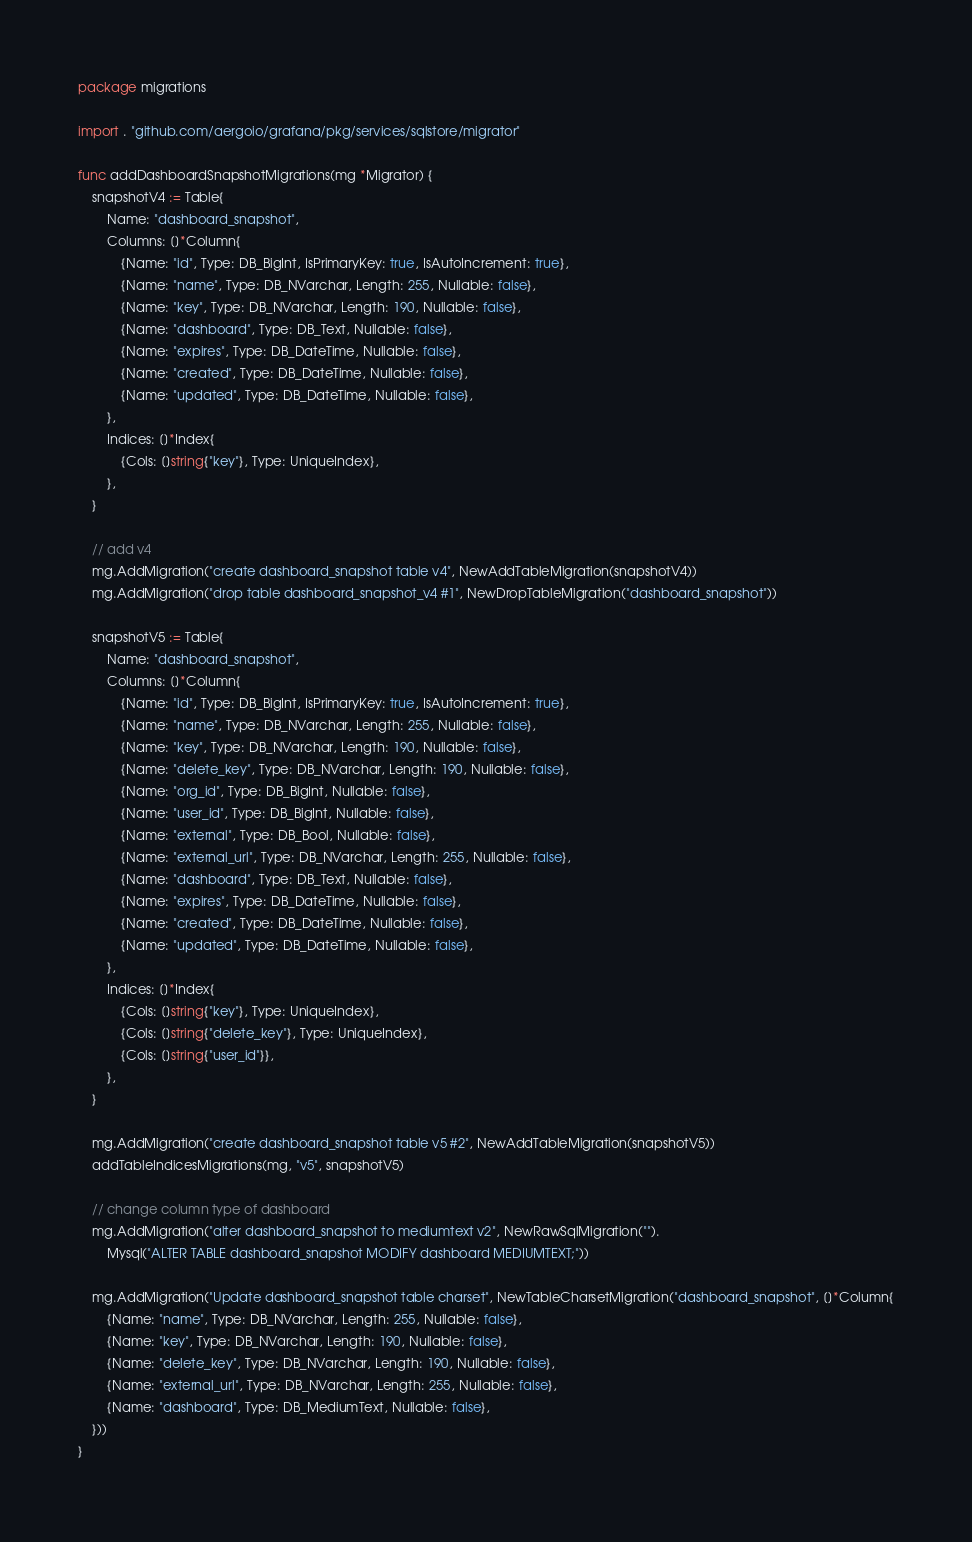<code> <loc_0><loc_0><loc_500><loc_500><_Go_>package migrations

import . "github.com/aergoio/grafana/pkg/services/sqlstore/migrator"

func addDashboardSnapshotMigrations(mg *Migrator) {
	snapshotV4 := Table{
		Name: "dashboard_snapshot",
		Columns: []*Column{
			{Name: "id", Type: DB_BigInt, IsPrimaryKey: true, IsAutoIncrement: true},
			{Name: "name", Type: DB_NVarchar, Length: 255, Nullable: false},
			{Name: "key", Type: DB_NVarchar, Length: 190, Nullable: false},
			{Name: "dashboard", Type: DB_Text, Nullable: false},
			{Name: "expires", Type: DB_DateTime, Nullable: false},
			{Name: "created", Type: DB_DateTime, Nullable: false},
			{Name: "updated", Type: DB_DateTime, Nullable: false},
		},
		Indices: []*Index{
			{Cols: []string{"key"}, Type: UniqueIndex},
		},
	}

	// add v4
	mg.AddMigration("create dashboard_snapshot table v4", NewAddTableMigration(snapshotV4))
	mg.AddMigration("drop table dashboard_snapshot_v4 #1", NewDropTableMigration("dashboard_snapshot"))

	snapshotV5 := Table{
		Name: "dashboard_snapshot",
		Columns: []*Column{
			{Name: "id", Type: DB_BigInt, IsPrimaryKey: true, IsAutoIncrement: true},
			{Name: "name", Type: DB_NVarchar, Length: 255, Nullable: false},
			{Name: "key", Type: DB_NVarchar, Length: 190, Nullable: false},
			{Name: "delete_key", Type: DB_NVarchar, Length: 190, Nullable: false},
			{Name: "org_id", Type: DB_BigInt, Nullable: false},
			{Name: "user_id", Type: DB_BigInt, Nullable: false},
			{Name: "external", Type: DB_Bool, Nullable: false},
			{Name: "external_url", Type: DB_NVarchar, Length: 255, Nullable: false},
			{Name: "dashboard", Type: DB_Text, Nullable: false},
			{Name: "expires", Type: DB_DateTime, Nullable: false},
			{Name: "created", Type: DB_DateTime, Nullable: false},
			{Name: "updated", Type: DB_DateTime, Nullable: false},
		},
		Indices: []*Index{
			{Cols: []string{"key"}, Type: UniqueIndex},
			{Cols: []string{"delete_key"}, Type: UniqueIndex},
			{Cols: []string{"user_id"}},
		},
	}

	mg.AddMigration("create dashboard_snapshot table v5 #2", NewAddTableMigration(snapshotV5))
	addTableIndicesMigrations(mg, "v5", snapshotV5)

	// change column type of dashboard
	mg.AddMigration("alter dashboard_snapshot to mediumtext v2", NewRawSqlMigration("").
		Mysql("ALTER TABLE dashboard_snapshot MODIFY dashboard MEDIUMTEXT;"))

	mg.AddMigration("Update dashboard_snapshot table charset", NewTableCharsetMigration("dashboard_snapshot", []*Column{
		{Name: "name", Type: DB_NVarchar, Length: 255, Nullable: false},
		{Name: "key", Type: DB_NVarchar, Length: 190, Nullable: false},
		{Name: "delete_key", Type: DB_NVarchar, Length: 190, Nullable: false},
		{Name: "external_url", Type: DB_NVarchar, Length: 255, Nullable: false},
		{Name: "dashboard", Type: DB_MediumText, Nullable: false},
	}))
}
</code> 